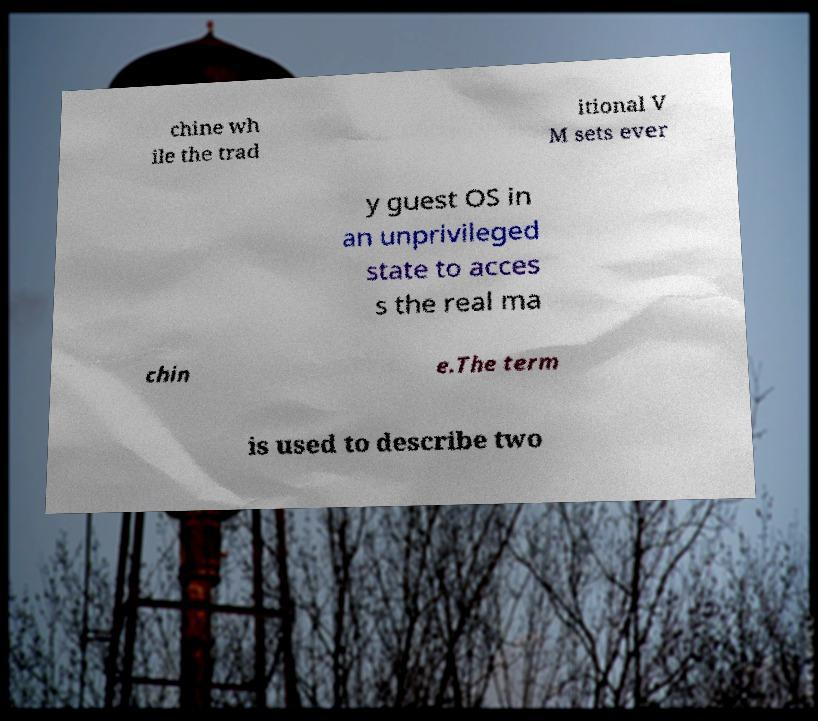Could you assist in decoding the text presented in this image and type it out clearly? chine wh ile the trad itional V M sets ever y guest OS in an unprivileged state to acces s the real ma chin e.The term is used to describe two 